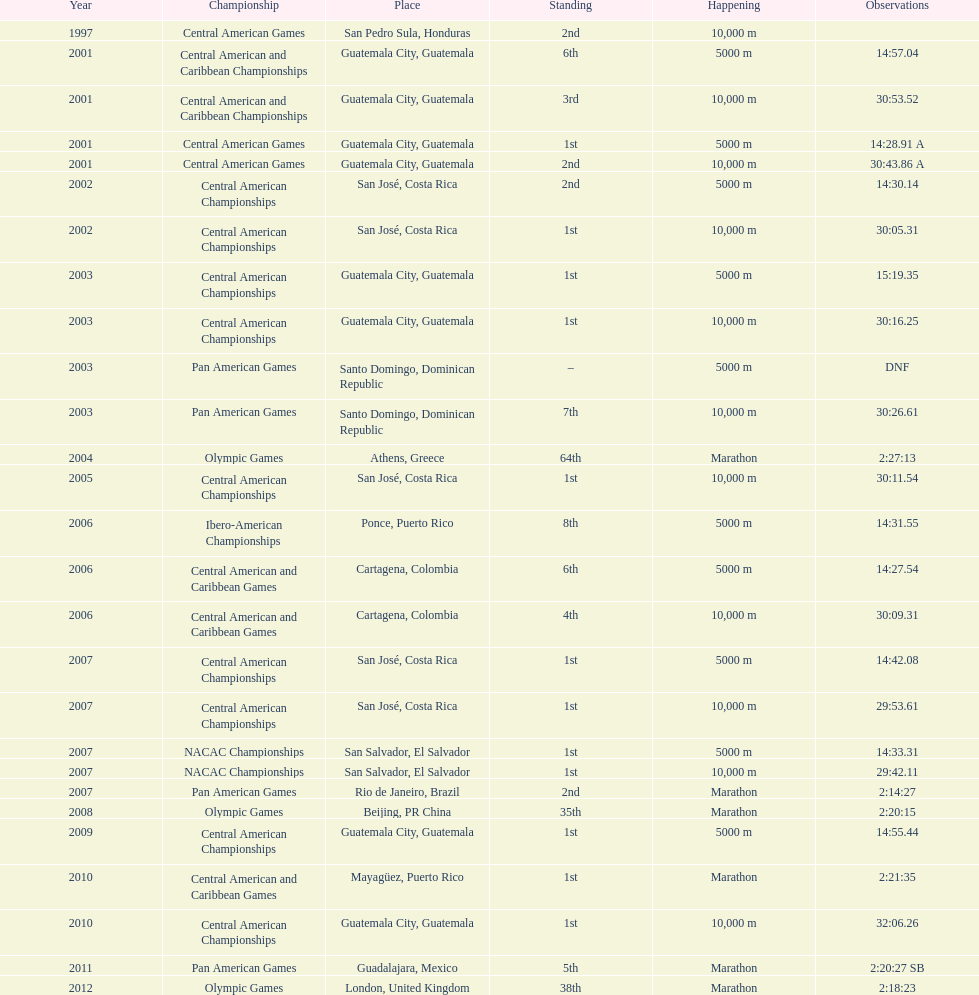What was the first competition this competitor competed in? Central American Games. 